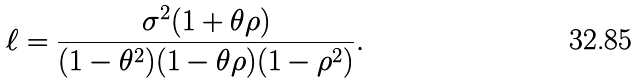<formula> <loc_0><loc_0><loc_500><loc_500>\ell = \frac { \sigma ^ { 2 } ( 1 + \theta \rho ) } { ( 1 - \theta ^ { 2 } ) ( 1 - \theta \rho ) ( 1 - \rho ^ { 2 } ) } .</formula> 